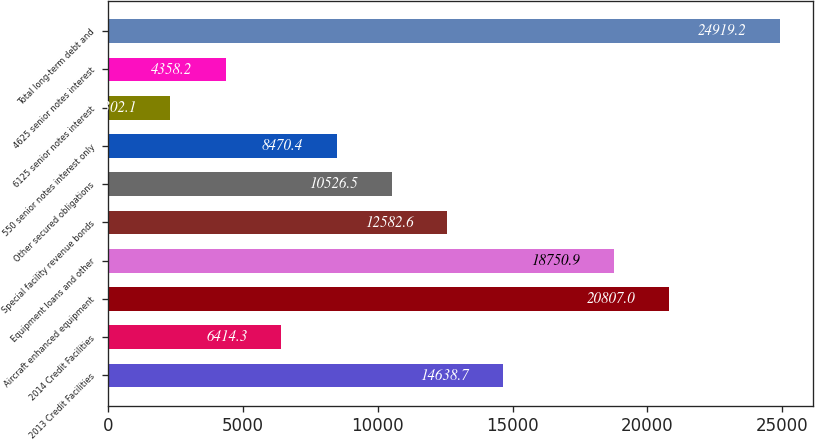Convert chart to OTSL. <chart><loc_0><loc_0><loc_500><loc_500><bar_chart><fcel>2013 Credit Facilities<fcel>2014 Credit Facilities<fcel>Aircraft enhanced equipment<fcel>Equipment loans and other<fcel>Special facility revenue bonds<fcel>Other secured obligations<fcel>550 senior notes interest only<fcel>6125 senior notes interest<fcel>4625 senior notes interest<fcel>Total long-term debt and<nl><fcel>14638.7<fcel>6414.3<fcel>20807<fcel>18750.9<fcel>12582.6<fcel>10526.5<fcel>8470.4<fcel>2302.1<fcel>4358.2<fcel>24919.2<nl></chart> 